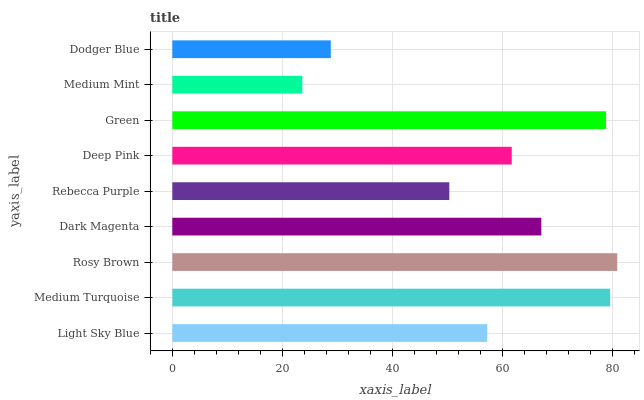Is Medium Mint the minimum?
Answer yes or no. Yes. Is Rosy Brown the maximum?
Answer yes or no. Yes. Is Medium Turquoise the minimum?
Answer yes or no. No. Is Medium Turquoise the maximum?
Answer yes or no. No. Is Medium Turquoise greater than Light Sky Blue?
Answer yes or no. Yes. Is Light Sky Blue less than Medium Turquoise?
Answer yes or no. Yes. Is Light Sky Blue greater than Medium Turquoise?
Answer yes or no. No. Is Medium Turquoise less than Light Sky Blue?
Answer yes or no. No. Is Deep Pink the high median?
Answer yes or no. Yes. Is Deep Pink the low median?
Answer yes or no. Yes. Is Rebecca Purple the high median?
Answer yes or no. No. Is Rebecca Purple the low median?
Answer yes or no. No. 